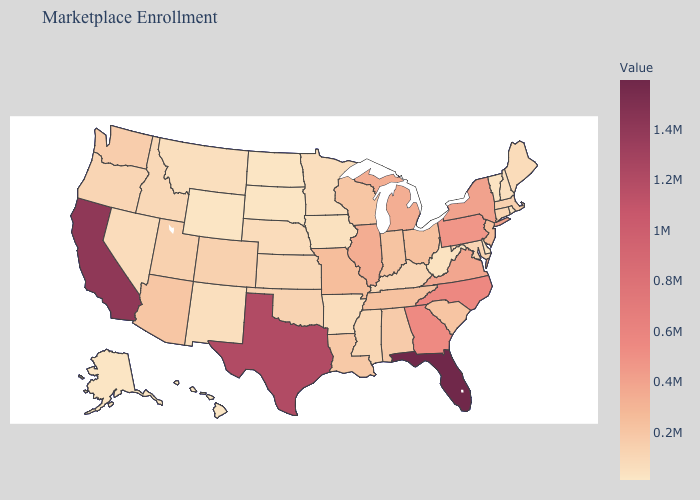Does Illinois have the highest value in the MidWest?
Short answer required. Yes. Which states have the highest value in the USA?
Concise answer only. Florida. Which states have the lowest value in the West?
Short answer required. Hawaii. Among the states that border West Virginia , does Kentucky have the lowest value?
Give a very brief answer. Yes. Is the legend a continuous bar?
Concise answer only. Yes. 